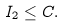Convert formula to latex. <formula><loc_0><loc_0><loc_500><loc_500>I _ { 2 } \leq C .</formula> 